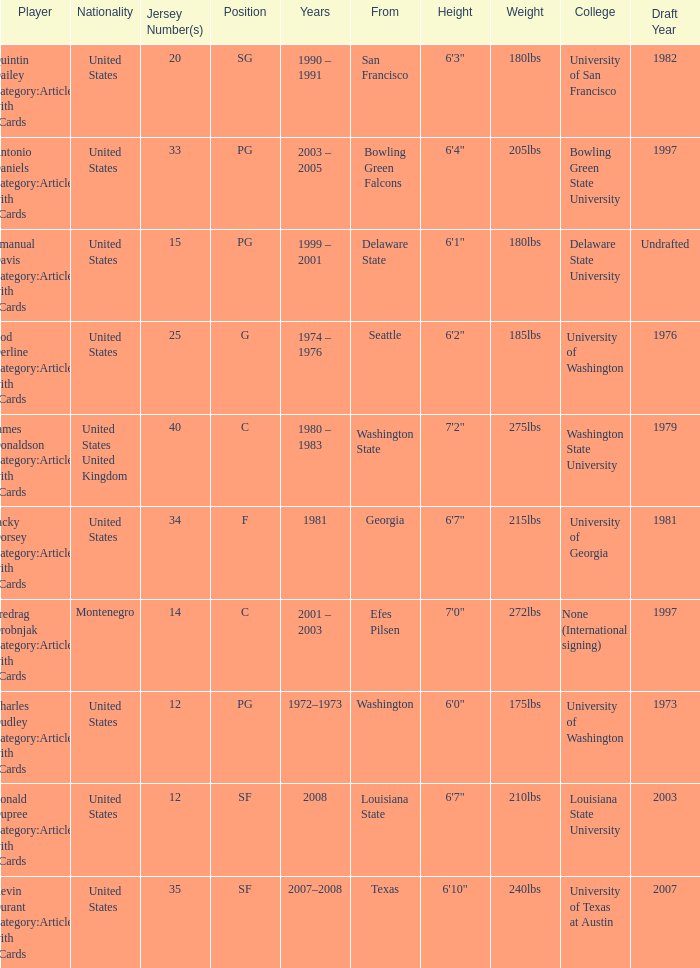What was the nationality of the players with a position of g? United States. 